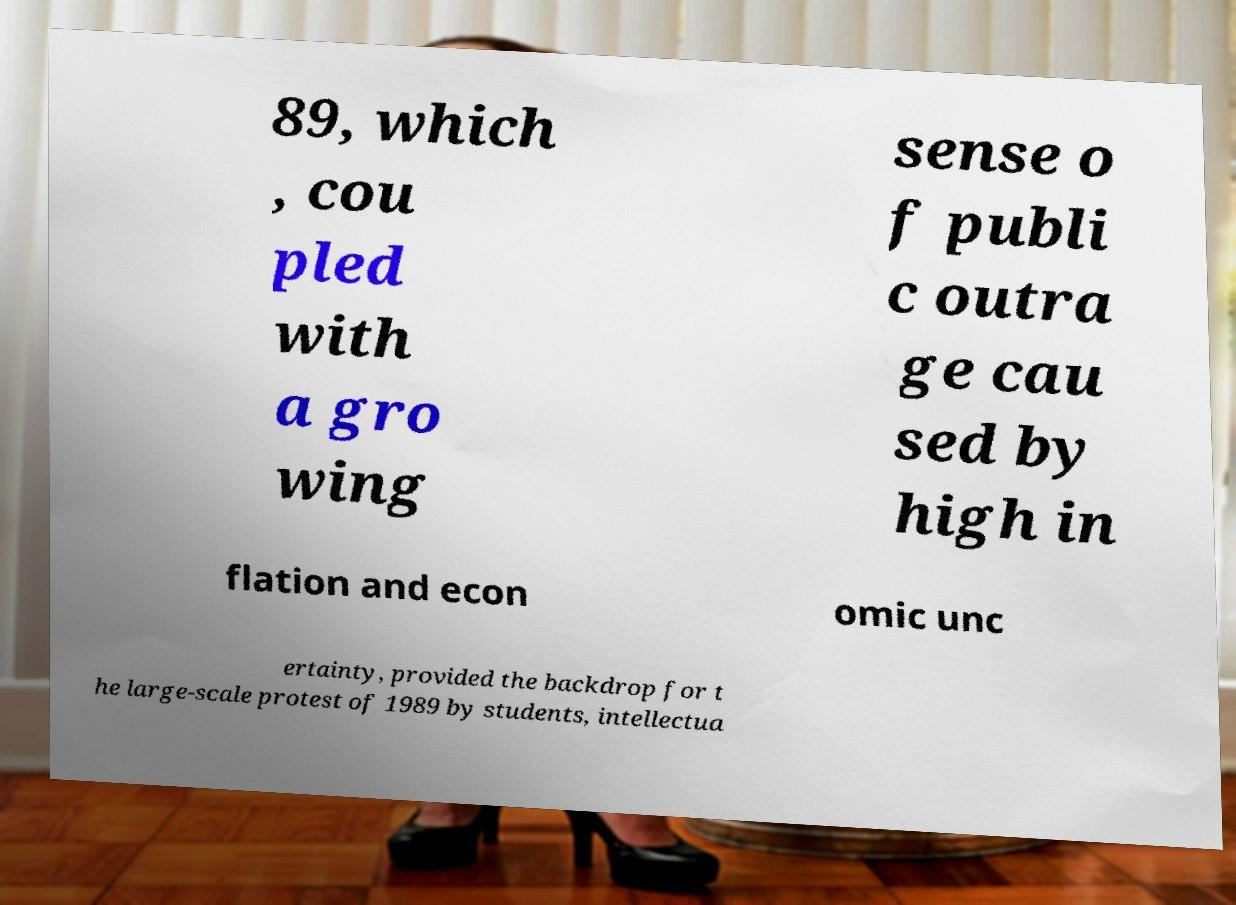For documentation purposes, I need the text within this image transcribed. Could you provide that? 89, which , cou pled with a gro wing sense o f publi c outra ge cau sed by high in flation and econ omic unc ertainty, provided the backdrop for t he large-scale protest of 1989 by students, intellectua 